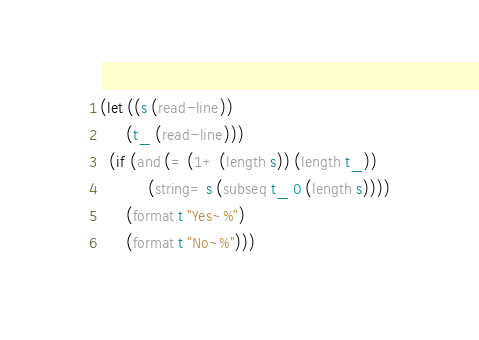<code> <loc_0><loc_0><loc_500><loc_500><_Lisp_>(let ((s (read-line))
      (t_ (read-line)))
  (if (and (= (1+ (length s)) (length t_))
           (string= s (subseq t_ 0 (length s))))
      (format t "Yes~%")
      (format t "No~%")))
</code> 